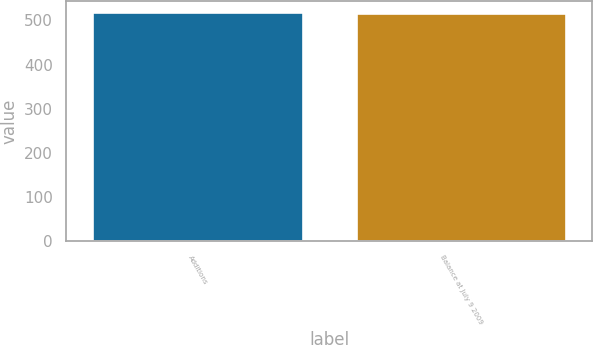Convert chart. <chart><loc_0><loc_0><loc_500><loc_500><bar_chart><fcel>Additions<fcel>Balance at July 9 2009<nl><fcel>518<fcel>516<nl></chart> 